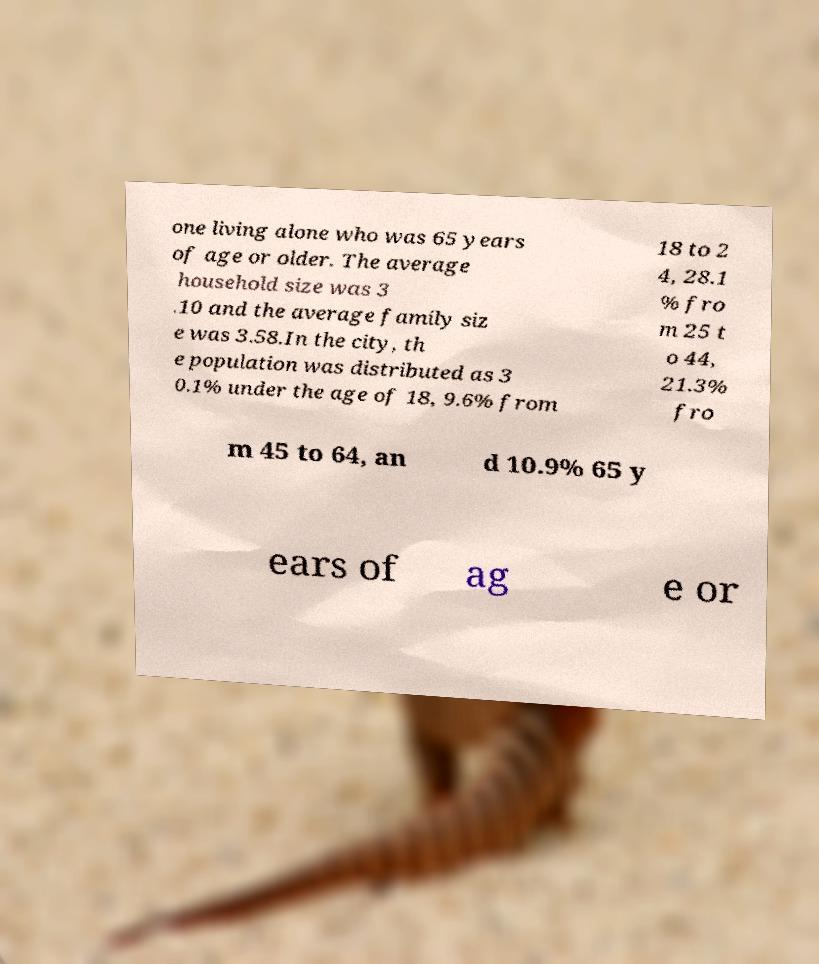Can you accurately transcribe the text from the provided image for me? one living alone who was 65 years of age or older. The average household size was 3 .10 and the average family siz e was 3.58.In the city, th e population was distributed as 3 0.1% under the age of 18, 9.6% from 18 to 2 4, 28.1 % fro m 25 t o 44, 21.3% fro m 45 to 64, an d 10.9% 65 y ears of ag e or 